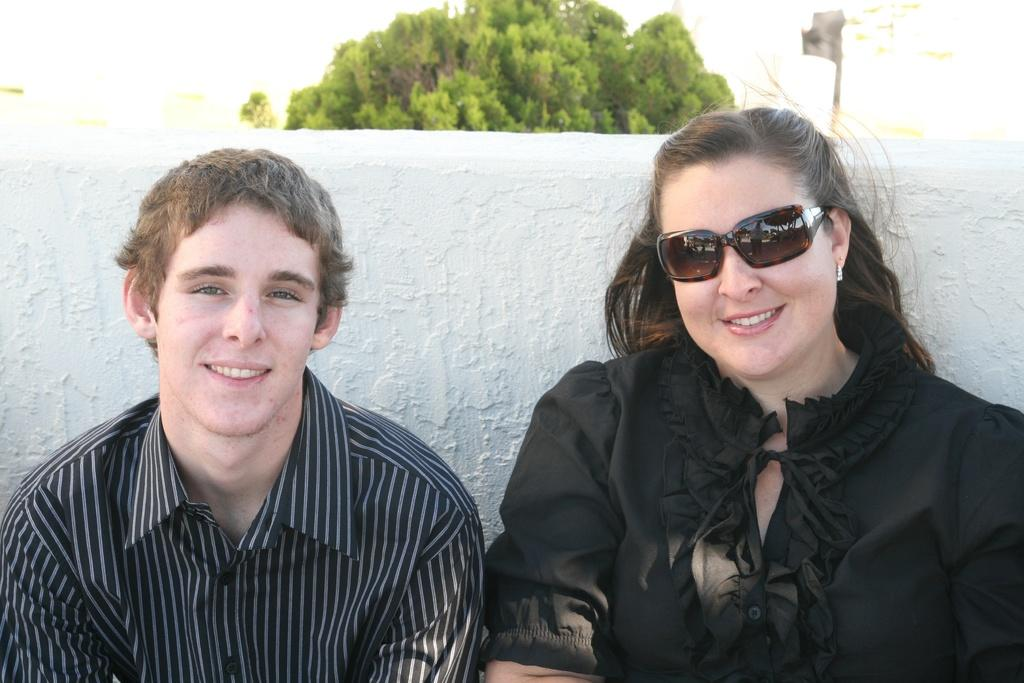Who are the people in the image? There is a woman and a man in the image. What are the expressions on their faces? Both the woman and the man are smiling in the image. What are they doing in the image? The woman and the man are posing for the picture. What can be seen in the background of the image? There is a wall in the background of the image. What is visible at the top of the image? There is a tree visible at the top of the image. What is the date on the calendar hanging on the wall in the image? There is no calendar present in the image, so it is not possible to determine the date. 